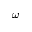Convert formula to latex. <formula><loc_0><loc_0><loc_500><loc_500>\omega</formula> 